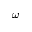Convert formula to latex. <formula><loc_0><loc_0><loc_500><loc_500>\omega</formula> 